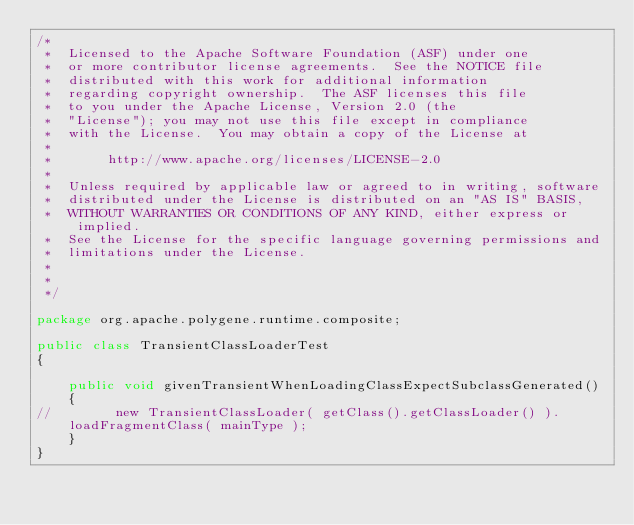Convert code to text. <code><loc_0><loc_0><loc_500><loc_500><_Java_>/*
 *  Licensed to the Apache Software Foundation (ASF) under one
 *  or more contributor license agreements.  See the NOTICE file
 *  distributed with this work for additional information
 *  regarding copyright ownership.  The ASF licenses this file
 *  to you under the Apache License, Version 2.0 (the
 *  "License"); you may not use this file except in compliance
 *  with the License.  You may obtain a copy of the License at
 *
 *       http://www.apache.org/licenses/LICENSE-2.0
 *
 *  Unless required by applicable law or agreed to in writing, software
 *  distributed under the License is distributed on an "AS IS" BASIS,
 *  WITHOUT WARRANTIES OR CONDITIONS OF ANY KIND, either express or implied.
 *  See the License for the specific language governing permissions and
 *  limitations under the License.
 *
 *
 */

package org.apache.polygene.runtime.composite;

public class TransientClassLoaderTest
{

    public void givenTransientWhenLoadingClassExpectSubclassGenerated()
    {
//        new TransientClassLoader( getClass().getClassLoader() ).loadFragmentClass( mainType );
    }
}
</code> 